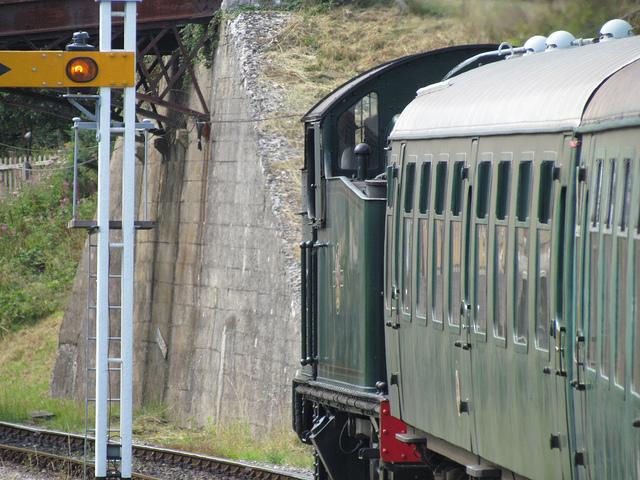Is this the pilot or the caboose of the train?
Write a very short answer. Caboose. Is there a stairway?
Quick response, please. No. What color is the train?
Write a very short answer. Green. 